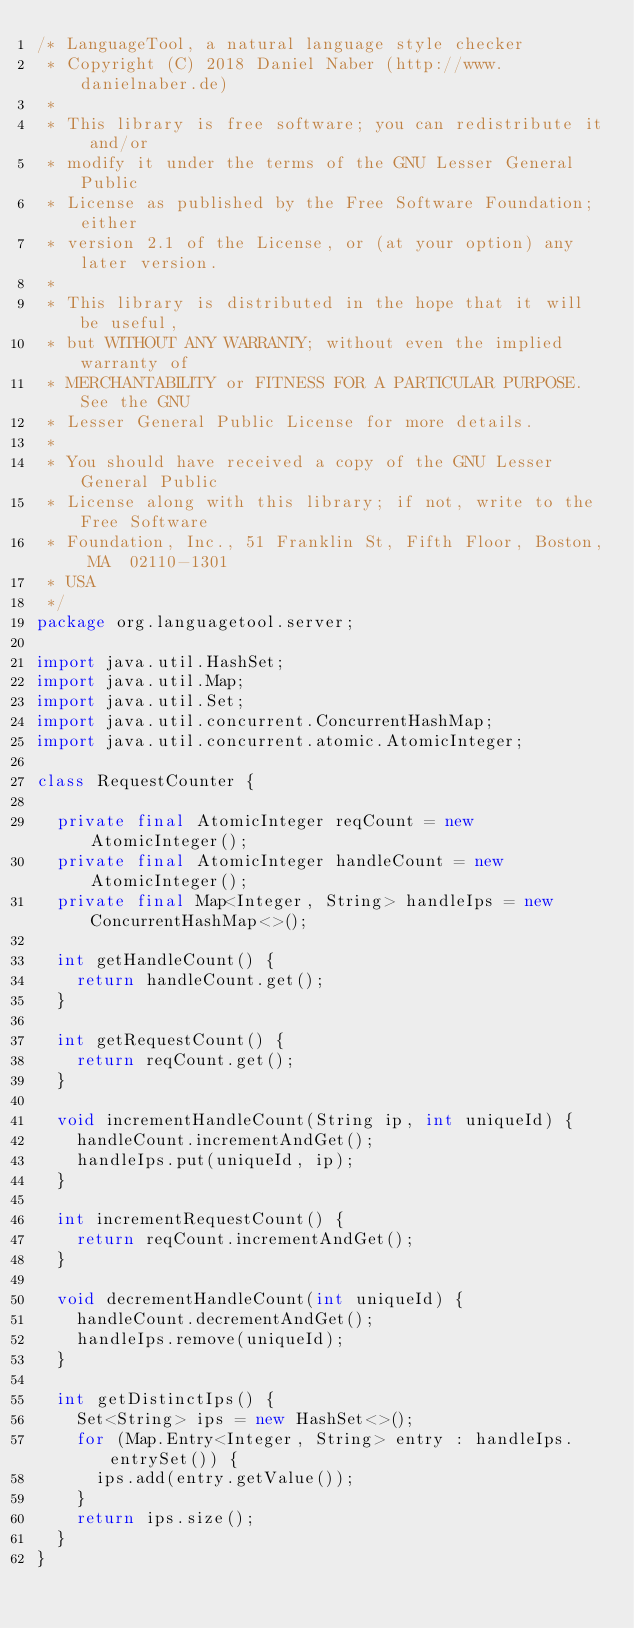Convert code to text. <code><loc_0><loc_0><loc_500><loc_500><_Java_>/* LanguageTool, a natural language style checker
 * Copyright (C) 2018 Daniel Naber (http://www.danielnaber.de)
 *
 * This library is free software; you can redistribute it and/or
 * modify it under the terms of the GNU Lesser General Public
 * License as published by the Free Software Foundation; either
 * version 2.1 of the License, or (at your option) any later version.
 *
 * This library is distributed in the hope that it will be useful,
 * but WITHOUT ANY WARRANTY; without even the implied warranty of
 * MERCHANTABILITY or FITNESS FOR A PARTICULAR PURPOSE.  See the GNU
 * Lesser General Public License for more details.
 *
 * You should have received a copy of the GNU Lesser General Public
 * License along with this library; if not, write to the Free Software
 * Foundation, Inc., 51 Franklin St, Fifth Floor, Boston, MA  02110-1301
 * USA
 */
package org.languagetool.server;

import java.util.HashSet;
import java.util.Map;
import java.util.Set;
import java.util.concurrent.ConcurrentHashMap;
import java.util.concurrent.atomic.AtomicInteger;

class RequestCounter {

  private final AtomicInteger reqCount = new AtomicInteger();
  private final AtomicInteger handleCount = new AtomicInteger();
  private final Map<Integer, String> handleIps = new ConcurrentHashMap<>();

  int getHandleCount() {
    return handleCount.get();
  }

  int getRequestCount() {
    return reqCount.get();
  }
  
  void incrementHandleCount(String ip, int uniqueId) {
    handleCount.incrementAndGet();
    handleIps.put(uniqueId, ip);
  }

  int incrementRequestCount() {
    return reqCount.incrementAndGet();
  }

  void decrementHandleCount(int uniqueId) {
    handleCount.decrementAndGet();
    handleIps.remove(uniqueId);
  }

  int getDistinctIps() {
    Set<String> ips = new HashSet<>();
    for (Map.Entry<Integer, String> entry : handleIps.entrySet()) {
      ips.add(entry.getValue());
    }
    return ips.size();
  }
}
</code> 